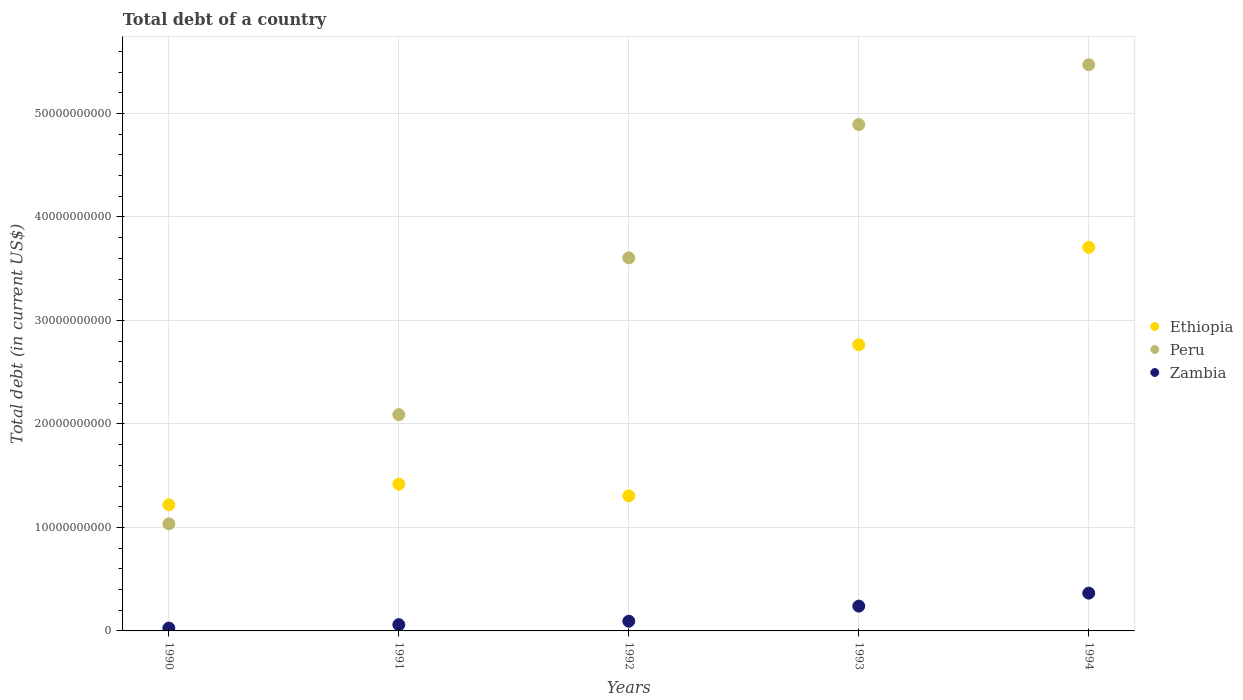How many different coloured dotlines are there?
Make the answer very short. 3. What is the debt in Zambia in 1991?
Provide a short and direct response. 6.06e+08. Across all years, what is the maximum debt in Zambia?
Offer a terse response. 3.65e+09. Across all years, what is the minimum debt in Zambia?
Your response must be concise. 2.77e+08. In which year was the debt in Peru maximum?
Offer a terse response. 1994. What is the total debt in Peru in the graph?
Your answer should be compact. 1.71e+11. What is the difference between the debt in Peru in 1991 and that in 1994?
Ensure brevity in your answer.  -3.38e+1. What is the difference between the debt in Ethiopia in 1992 and the debt in Zambia in 1990?
Make the answer very short. 1.28e+1. What is the average debt in Peru per year?
Give a very brief answer. 3.42e+1. In the year 1992, what is the difference between the debt in Ethiopia and debt in Peru?
Make the answer very short. -2.30e+1. In how many years, is the debt in Peru greater than 24000000000 US$?
Provide a short and direct response. 3. What is the ratio of the debt in Zambia in 1992 to that in 1994?
Make the answer very short. 0.26. Is the difference between the debt in Ethiopia in 1993 and 1994 greater than the difference between the debt in Peru in 1993 and 1994?
Give a very brief answer. No. What is the difference between the highest and the second highest debt in Zambia?
Your response must be concise. 1.25e+09. What is the difference between the highest and the lowest debt in Peru?
Your response must be concise. 4.44e+1. In how many years, is the debt in Ethiopia greater than the average debt in Ethiopia taken over all years?
Provide a succinct answer. 2. Does the debt in Peru monotonically increase over the years?
Make the answer very short. Yes. How many dotlines are there?
Provide a short and direct response. 3. What is the difference between two consecutive major ticks on the Y-axis?
Provide a short and direct response. 1.00e+1. Are the values on the major ticks of Y-axis written in scientific E-notation?
Your response must be concise. No. Does the graph contain grids?
Your answer should be very brief. Yes. How many legend labels are there?
Provide a succinct answer. 3. What is the title of the graph?
Give a very brief answer. Total debt of a country. What is the label or title of the Y-axis?
Provide a succinct answer. Total debt (in current US$). What is the Total debt (in current US$) of Ethiopia in 1990?
Provide a short and direct response. 1.22e+1. What is the Total debt (in current US$) in Peru in 1990?
Your response must be concise. 1.03e+1. What is the Total debt (in current US$) of Zambia in 1990?
Your response must be concise. 2.77e+08. What is the Total debt (in current US$) of Ethiopia in 1991?
Provide a succinct answer. 1.42e+1. What is the Total debt (in current US$) in Peru in 1991?
Your answer should be compact. 2.09e+1. What is the Total debt (in current US$) of Zambia in 1991?
Your answer should be very brief. 6.06e+08. What is the Total debt (in current US$) of Ethiopia in 1992?
Offer a very short reply. 1.31e+1. What is the Total debt (in current US$) in Peru in 1992?
Keep it short and to the point. 3.60e+1. What is the Total debt (in current US$) of Zambia in 1992?
Make the answer very short. 9.38e+08. What is the Total debt (in current US$) of Ethiopia in 1993?
Your response must be concise. 2.76e+1. What is the Total debt (in current US$) in Peru in 1993?
Keep it short and to the point. 4.89e+1. What is the Total debt (in current US$) of Zambia in 1993?
Make the answer very short. 2.40e+09. What is the Total debt (in current US$) of Ethiopia in 1994?
Your answer should be compact. 3.71e+1. What is the Total debt (in current US$) of Peru in 1994?
Your response must be concise. 5.47e+1. What is the Total debt (in current US$) of Zambia in 1994?
Your response must be concise. 3.65e+09. Across all years, what is the maximum Total debt (in current US$) in Ethiopia?
Your answer should be very brief. 3.71e+1. Across all years, what is the maximum Total debt (in current US$) in Peru?
Your answer should be compact. 5.47e+1. Across all years, what is the maximum Total debt (in current US$) in Zambia?
Your answer should be compact. 3.65e+09. Across all years, what is the minimum Total debt (in current US$) in Ethiopia?
Provide a short and direct response. 1.22e+1. Across all years, what is the minimum Total debt (in current US$) in Peru?
Provide a succinct answer. 1.03e+1. Across all years, what is the minimum Total debt (in current US$) in Zambia?
Offer a very short reply. 2.77e+08. What is the total Total debt (in current US$) in Ethiopia in the graph?
Your answer should be compact. 1.04e+11. What is the total Total debt (in current US$) in Peru in the graph?
Offer a very short reply. 1.71e+11. What is the total Total debt (in current US$) of Zambia in the graph?
Make the answer very short. 7.87e+09. What is the difference between the Total debt (in current US$) of Ethiopia in 1990 and that in 1991?
Offer a very short reply. -2.00e+09. What is the difference between the Total debt (in current US$) in Peru in 1990 and that in 1991?
Your answer should be compact. -1.05e+1. What is the difference between the Total debt (in current US$) in Zambia in 1990 and that in 1991?
Offer a very short reply. -3.29e+08. What is the difference between the Total debt (in current US$) in Ethiopia in 1990 and that in 1992?
Your answer should be compact. -8.65e+08. What is the difference between the Total debt (in current US$) in Peru in 1990 and that in 1992?
Your answer should be compact. -2.57e+1. What is the difference between the Total debt (in current US$) of Zambia in 1990 and that in 1992?
Give a very brief answer. -6.61e+08. What is the difference between the Total debt (in current US$) in Ethiopia in 1990 and that in 1993?
Your answer should be compact. -1.55e+1. What is the difference between the Total debt (in current US$) of Peru in 1990 and that in 1993?
Offer a very short reply. -3.86e+1. What is the difference between the Total debt (in current US$) of Zambia in 1990 and that in 1993?
Ensure brevity in your answer.  -2.12e+09. What is the difference between the Total debt (in current US$) in Ethiopia in 1990 and that in 1994?
Give a very brief answer. -2.49e+1. What is the difference between the Total debt (in current US$) of Peru in 1990 and that in 1994?
Your answer should be very brief. -4.44e+1. What is the difference between the Total debt (in current US$) of Zambia in 1990 and that in 1994?
Your response must be concise. -3.38e+09. What is the difference between the Total debt (in current US$) of Ethiopia in 1991 and that in 1992?
Your response must be concise. 1.13e+09. What is the difference between the Total debt (in current US$) in Peru in 1991 and that in 1992?
Make the answer very short. -1.51e+1. What is the difference between the Total debt (in current US$) of Zambia in 1991 and that in 1992?
Keep it short and to the point. -3.32e+08. What is the difference between the Total debt (in current US$) of Ethiopia in 1991 and that in 1993?
Ensure brevity in your answer.  -1.35e+1. What is the difference between the Total debt (in current US$) of Peru in 1991 and that in 1993?
Keep it short and to the point. -2.80e+1. What is the difference between the Total debt (in current US$) of Zambia in 1991 and that in 1993?
Offer a very short reply. -1.79e+09. What is the difference between the Total debt (in current US$) in Ethiopia in 1991 and that in 1994?
Provide a short and direct response. -2.29e+1. What is the difference between the Total debt (in current US$) in Peru in 1991 and that in 1994?
Your response must be concise. -3.38e+1. What is the difference between the Total debt (in current US$) of Zambia in 1991 and that in 1994?
Provide a short and direct response. -3.05e+09. What is the difference between the Total debt (in current US$) in Ethiopia in 1992 and that in 1993?
Keep it short and to the point. -1.46e+1. What is the difference between the Total debt (in current US$) in Peru in 1992 and that in 1993?
Ensure brevity in your answer.  -1.29e+1. What is the difference between the Total debt (in current US$) in Zambia in 1992 and that in 1993?
Provide a succinct answer. -1.46e+09. What is the difference between the Total debt (in current US$) in Ethiopia in 1992 and that in 1994?
Your answer should be compact. -2.40e+1. What is the difference between the Total debt (in current US$) of Peru in 1992 and that in 1994?
Offer a terse response. -1.87e+1. What is the difference between the Total debt (in current US$) in Zambia in 1992 and that in 1994?
Provide a short and direct response. -2.71e+09. What is the difference between the Total debt (in current US$) of Ethiopia in 1993 and that in 1994?
Give a very brief answer. -9.42e+09. What is the difference between the Total debt (in current US$) in Peru in 1993 and that in 1994?
Your answer should be very brief. -5.78e+09. What is the difference between the Total debt (in current US$) in Zambia in 1993 and that in 1994?
Provide a short and direct response. -1.25e+09. What is the difference between the Total debt (in current US$) in Ethiopia in 1990 and the Total debt (in current US$) in Peru in 1991?
Give a very brief answer. -8.71e+09. What is the difference between the Total debt (in current US$) of Ethiopia in 1990 and the Total debt (in current US$) of Zambia in 1991?
Provide a succinct answer. 1.16e+1. What is the difference between the Total debt (in current US$) in Peru in 1990 and the Total debt (in current US$) in Zambia in 1991?
Your answer should be compact. 9.74e+09. What is the difference between the Total debt (in current US$) of Ethiopia in 1990 and the Total debt (in current US$) of Peru in 1992?
Keep it short and to the point. -2.39e+1. What is the difference between the Total debt (in current US$) in Ethiopia in 1990 and the Total debt (in current US$) in Zambia in 1992?
Offer a terse response. 1.12e+1. What is the difference between the Total debt (in current US$) of Peru in 1990 and the Total debt (in current US$) of Zambia in 1992?
Provide a succinct answer. 9.41e+09. What is the difference between the Total debt (in current US$) in Ethiopia in 1990 and the Total debt (in current US$) in Peru in 1993?
Make the answer very short. -3.67e+1. What is the difference between the Total debt (in current US$) in Ethiopia in 1990 and the Total debt (in current US$) in Zambia in 1993?
Provide a short and direct response. 9.79e+09. What is the difference between the Total debt (in current US$) in Peru in 1990 and the Total debt (in current US$) in Zambia in 1993?
Your response must be concise. 7.95e+09. What is the difference between the Total debt (in current US$) of Ethiopia in 1990 and the Total debt (in current US$) of Peru in 1994?
Provide a short and direct response. -4.25e+1. What is the difference between the Total debt (in current US$) in Ethiopia in 1990 and the Total debt (in current US$) in Zambia in 1994?
Provide a short and direct response. 8.53e+09. What is the difference between the Total debt (in current US$) in Peru in 1990 and the Total debt (in current US$) in Zambia in 1994?
Provide a short and direct response. 6.69e+09. What is the difference between the Total debt (in current US$) in Ethiopia in 1991 and the Total debt (in current US$) in Peru in 1992?
Your answer should be compact. -2.19e+1. What is the difference between the Total debt (in current US$) in Ethiopia in 1991 and the Total debt (in current US$) in Zambia in 1992?
Offer a terse response. 1.32e+1. What is the difference between the Total debt (in current US$) of Peru in 1991 and the Total debt (in current US$) of Zambia in 1992?
Give a very brief answer. 2.00e+1. What is the difference between the Total debt (in current US$) of Ethiopia in 1991 and the Total debt (in current US$) of Peru in 1993?
Ensure brevity in your answer.  -3.47e+1. What is the difference between the Total debt (in current US$) of Ethiopia in 1991 and the Total debt (in current US$) of Zambia in 1993?
Ensure brevity in your answer.  1.18e+1. What is the difference between the Total debt (in current US$) of Peru in 1991 and the Total debt (in current US$) of Zambia in 1993?
Your answer should be very brief. 1.85e+1. What is the difference between the Total debt (in current US$) of Ethiopia in 1991 and the Total debt (in current US$) of Peru in 1994?
Keep it short and to the point. -4.05e+1. What is the difference between the Total debt (in current US$) of Ethiopia in 1991 and the Total debt (in current US$) of Zambia in 1994?
Provide a succinct answer. 1.05e+1. What is the difference between the Total debt (in current US$) in Peru in 1991 and the Total debt (in current US$) in Zambia in 1994?
Give a very brief answer. 1.72e+1. What is the difference between the Total debt (in current US$) in Ethiopia in 1992 and the Total debt (in current US$) in Peru in 1993?
Your response must be concise. -3.59e+1. What is the difference between the Total debt (in current US$) in Ethiopia in 1992 and the Total debt (in current US$) in Zambia in 1993?
Make the answer very short. 1.07e+1. What is the difference between the Total debt (in current US$) of Peru in 1992 and the Total debt (in current US$) of Zambia in 1993?
Offer a terse response. 3.36e+1. What is the difference between the Total debt (in current US$) in Ethiopia in 1992 and the Total debt (in current US$) in Peru in 1994?
Keep it short and to the point. -4.17e+1. What is the difference between the Total debt (in current US$) of Ethiopia in 1992 and the Total debt (in current US$) of Zambia in 1994?
Make the answer very short. 9.40e+09. What is the difference between the Total debt (in current US$) in Peru in 1992 and the Total debt (in current US$) in Zambia in 1994?
Make the answer very short. 3.24e+1. What is the difference between the Total debt (in current US$) of Ethiopia in 1993 and the Total debt (in current US$) of Peru in 1994?
Keep it short and to the point. -2.71e+1. What is the difference between the Total debt (in current US$) in Ethiopia in 1993 and the Total debt (in current US$) in Zambia in 1994?
Offer a terse response. 2.40e+1. What is the difference between the Total debt (in current US$) of Peru in 1993 and the Total debt (in current US$) of Zambia in 1994?
Offer a very short reply. 4.53e+1. What is the average Total debt (in current US$) of Ethiopia per year?
Ensure brevity in your answer.  2.08e+1. What is the average Total debt (in current US$) in Peru per year?
Keep it short and to the point. 3.42e+1. What is the average Total debt (in current US$) of Zambia per year?
Make the answer very short. 1.57e+09. In the year 1990, what is the difference between the Total debt (in current US$) in Ethiopia and Total debt (in current US$) in Peru?
Offer a very short reply. 1.84e+09. In the year 1990, what is the difference between the Total debt (in current US$) in Ethiopia and Total debt (in current US$) in Zambia?
Provide a succinct answer. 1.19e+1. In the year 1990, what is the difference between the Total debt (in current US$) in Peru and Total debt (in current US$) in Zambia?
Your answer should be compact. 1.01e+1. In the year 1991, what is the difference between the Total debt (in current US$) of Ethiopia and Total debt (in current US$) of Peru?
Offer a very short reply. -6.71e+09. In the year 1991, what is the difference between the Total debt (in current US$) of Ethiopia and Total debt (in current US$) of Zambia?
Provide a short and direct response. 1.36e+1. In the year 1991, what is the difference between the Total debt (in current US$) of Peru and Total debt (in current US$) of Zambia?
Give a very brief answer. 2.03e+1. In the year 1992, what is the difference between the Total debt (in current US$) in Ethiopia and Total debt (in current US$) in Peru?
Your answer should be very brief. -2.30e+1. In the year 1992, what is the difference between the Total debt (in current US$) in Ethiopia and Total debt (in current US$) in Zambia?
Your answer should be compact. 1.21e+1. In the year 1992, what is the difference between the Total debt (in current US$) in Peru and Total debt (in current US$) in Zambia?
Make the answer very short. 3.51e+1. In the year 1993, what is the difference between the Total debt (in current US$) of Ethiopia and Total debt (in current US$) of Peru?
Ensure brevity in your answer.  -2.13e+1. In the year 1993, what is the difference between the Total debt (in current US$) in Ethiopia and Total debt (in current US$) in Zambia?
Your answer should be very brief. 2.52e+1. In the year 1993, what is the difference between the Total debt (in current US$) in Peru and Total debt (in current US$) in Zambia?
Your answer should be compact. 4.65e+1. In the year 1994, what is the difference between the Total debt (in current US$) of Ethiopia and Total debt (in current US$) of Peru?
Provide a short and direct response. -1.76e+1. In the year 1994, what is the difference between the Total debt (in current US$) in Ethiopia and Total debt (in current US$) in Zambia?
Provide a succinct answer. 3.34e+1. In the year 1994, what is the difference between the Total debt (in current US$) in Peru and Total debt (in current US$) in Zambia?
Your answer should be very brief. 5.11e+1. What is the ratio of the Total debt (in current US$) of Ethiopia in 1990 to that in 1991?
Make the answer very short. 0.86. What is the ratio of the Total debt (in current US$) in Peru in 1990 to that in 1991?
Give a very brief answer. 0.5. What is the ratio of the Total debt (in current US$) in Zambia in 1990 to that in 1991?
Your response must be concise. 0.46. What is the ratio of the Total debt (in current US$) in Ethiopia in 1990 to that in 1992?
Provide a succinct answer. 0.93. What is the ratio of the Total debt (in current US$) of Peru in 1990 to that in 1992?
Your answer should be compact. 0.29. What is the ratio of the Total debt (in current US$) of Zambia in 1990 to that in 1992?
Your answer should be very brief. 0.3. What is the ratio of the Total debt (in current US$) in Ethiopia in 1990 to that in 1993?
Provide a short and direct response. 0.44. What is the ratio of the Total debt (in current US$) in Peru in 1990 to that in 1993?
Offer a terse response. 0.21. What is the ratio of the Total debt (in current US$) in Zambia in 1990 to that in 1993?
Give a very brief answer. 0.12. What is the ratio of the Total debt (in current US$) of Ethiopia in 1990 to that in 1994?
Provide a succinct answer. 0.33. What is the ratio of the Total debt (in current US$) of Peru in 1990 to that in 1994?
Your answer should be very brief. 0.19. What is the ratio of the Total debt (in current US$) of Zambia in 1990 to that in 1994?
Offer a very short reply. 0.08. What is the ratio of the Total debt (in current US$) of Ethiopia in 1991 to that in 1992?
Make the answer very short. 1.09. What is the ratio of the Total debt (in current US$) of Peru in 1991 to that in 1992?
Offer a terse response. 0.58. What is the ratio of the Total debt (in current US$) in Zambia in 1991 to that in 1992?
Your answer should be very brief. 0.65. What is the ratio of the Total debt (in current US$) of Ethiopia in 1991 to that in 1993?
Provide a short and direct response. 0.51. What is the ratio of the Total debt (in current US$) in Peru in 1991 to that in 1993?
Offer a terse response. 0.43. What is the ratio of the Total debt (in current US$) in Zambia in 1991 to that in 1993?
Ensure brevity in your answer.  0.25. What is the ratio of the Total debt (in current US$) of Ethiopia in 1991 to that in 1994?
Keep it short and to the point. 0.38. What is the ratio of the Total debt (in current US$) in Peru in 1991 to that in 1994?
Give a very brief answer. 0.38. What is the ratio of the Total debt (in current US$) in Zambia in 1991 to that in 1994?
Provide a short and direct response. 0.17. What is the ratio of the Total debt (in current US$) of Ethiopia in 1992 to that in 1993?
Provide a succinct answer. 0.47. What is the ratio of the Total debt (in current US$) of Peru in 1992 to that in 1993?
Your answer should be compact. 0.74. What is the ratio of the Total debt (in current US$) in Zambia in 1992 to that in 1993?
Offer a very short reply. 0.39. What is the ratio of the Total debt (in current US$) in Ethiopia in 1992 to that in 1994?
Ensure brevity in your answer.  0.35. What is the ratio of the Total debt (in current US$) in Peru in 1992 to that in 1994?
Make the answer very short. 0.66. What is the ratio of the Total debt (in current US$) in Zambia in 1992 to that in 1994?
Offer a terse response. 0.26. What is the ratio of the Total debt (in current US$) in Ethiopia in 1993 to that in 1994?
Your response must be concise. 0.75. What is the ratio of the Total debt (in current US$) in Peru in 1993 to that in 1994?
Offer a very short reply. 0.89. What is the ratio of the Total debt (in current US$) in Zambia in 1993 to that in 1994?
Provide a succinct answer. 0.66. What is the difference between the highest and the second highest Total debt (in current US$) in Ethiopia?
Provide a short and direct response. 9.42e+09. What is the difference between the highest and the second highest Total debt (in current US$) in Peru?
Your response must be concise. 5.78e+09. What is the difference between the highest and the second highest Total debt (in current US$) in Zambia?
Ensure brevity in your answer.  1.25e+09. What is the difference between the highest and the lowest Total debt (in current US$) of Ethiopia?
Keep it short and to the point. 2.49e+1. What is the difference between the highest and the lowest Total debt (in current US$) of Peru?
Provide a short and direct response. 4.44e+1. What is the difference between the highest and the lowest Total debt (in current US$) in Zambia?
Ensure brevity in your answer.  3.38e+09. 